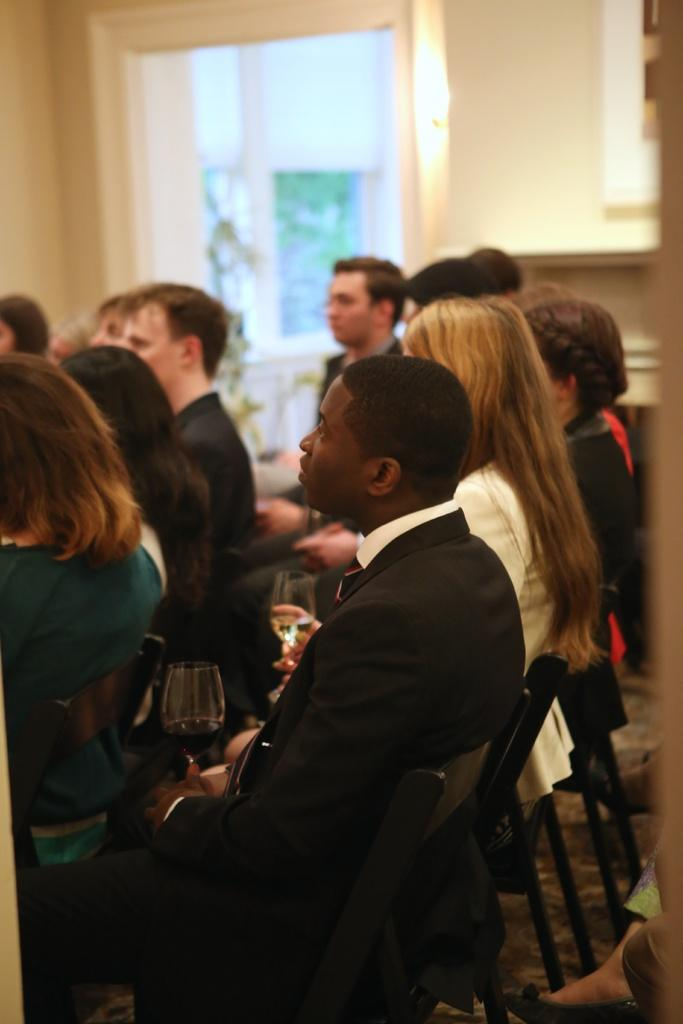How many people are in the image? There are people in the image, but the exact number is not specified. What are the people wearing? The people in the image are wearing clothes. What are the people doing in the image? The people are sitting on chairs in the image. What is present on the table in the image? There is a wine glass in the image. What can be seen outside the window in the image? The facts do not specify what can be seen outside the window. What type of surface is visible beneath the people in the image? There is a floor visible in the image. What type of zephyr can be seen blowing through the room in the image? There is no mention of a zephyr or any wind in the image. 